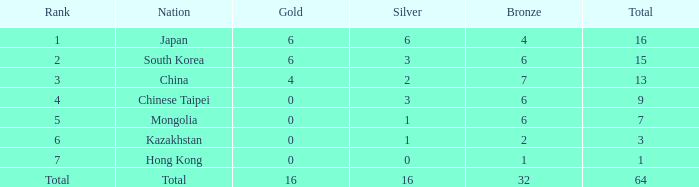Which bronze is the smallest one that has a rank of 3, and a silver below 2? None. 